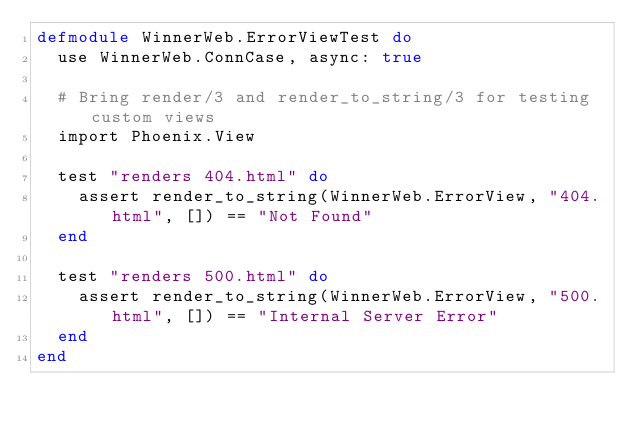Convert code to text. <code><loc_0><loc_0><loc_500><loc_500><_Elixir_>defmodule WinnerWeb.ErrorViewTest do
  use WinnerWeb.ConnCase, async: true

  # Bring render/3 and render_to_string/3 for testing custom views
  import Phoenix.View

  test "renders 404.html" do
    assert render_to_string(WinnerWeb.ErrorView, "404.html", []) == "Not Found"
  end

  test "renders 500.html" do
    assert render_to_string(WinnerWeb.ErrorView, "500.html", []) == "Internal Server Error"
  end
end
</code> 